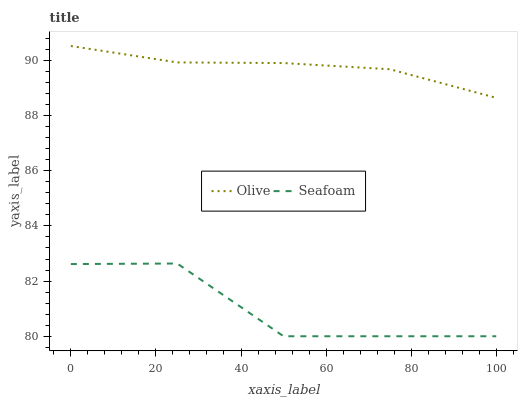Does Seafoam have the minimum area under the curve?
Answer yes or no. Yes. Does Seafoam have the maximum area under the curve?
Answer yes or no. No. Is Seafoam the roughest?
Answer yes or no. Yes. Is Seafoam the smoothest?
Answer yes or no. No. Does Seafoam have the highest value?
Answer yes or no. No. Is Seafoam less than Olive?
Answer yes or no. Yes. Is Olive greater than Seafoam?
Answer yes or no. Yes. Does Seafoam intersect Olive?
Answer yes or no. No. 